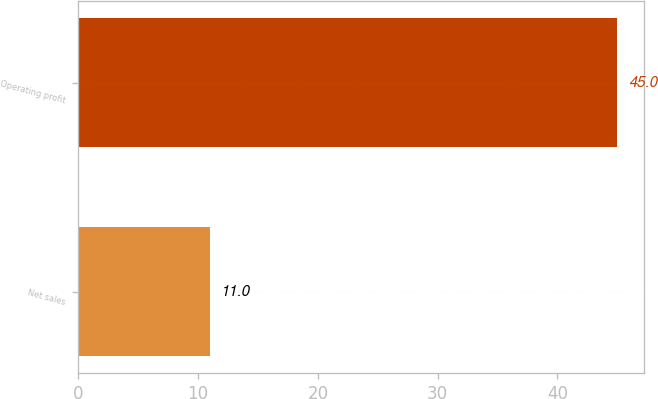<chart> <loc_0><loc_0><loc_500><loc_500><bar_chart><fcel>Net sales<fcel>Operating profit<nl><fcel>11<fcel>45<nl></chart> 